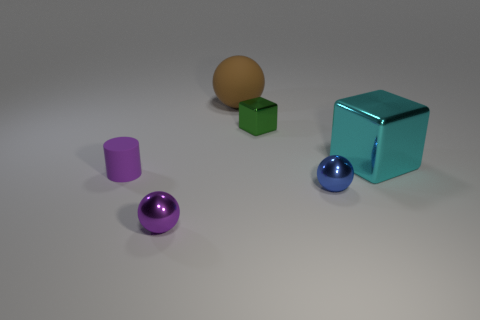There is a green cube; are there any balls on the left side of it?
Your answer should be very brief. Yes. What shape is the purple metal object?
Your answer should be very brief. Sphere. What number of things are metallic things left of the brown rubber ball or small cyan metal spheres?
Your answer should be compact. 1. How many other things are the same color as the small matte cylinder?
Provide a succinct answer. 1. There is a big rubber ball; is its color the same as the large object right of the blue sphere?
Provide a short and direct response. No. There is another metal thing that is the same shape as the cyan thing; what is its color?
Your answer should be very brief. Green. Does the tiny cube have the same material as the large thing right of the blue metallic thing?
Provide a short and direct response. Yes. What color is the large shiny object?
Provide a succinct answer. Cyan. The sphere right of the big brown rubber object on the right side of the shiny object left of the brown matte thing is what color?
Provide a succinct answer. Blue. There is a large matte object; is it the same shape as the shiny object that is right of the small blue object?
Provide a succinct answer. No. 